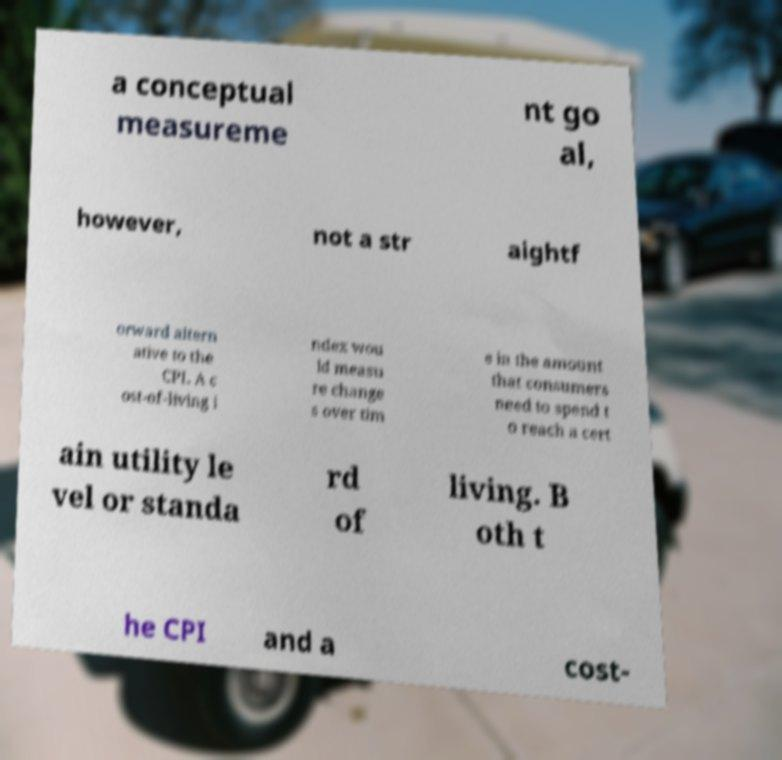Please read and relay the text visible in this image. What does it say? a conceptual measureme nt go al, however, not a str aightf orward altern ative to the CPI. A c ost-of-living i ndex wou ld measu re change s over tim e in the amount that consumers need to spend t o reach a cert ain utility le vel or standa rd of living. B oth t he CPI and a cost- 